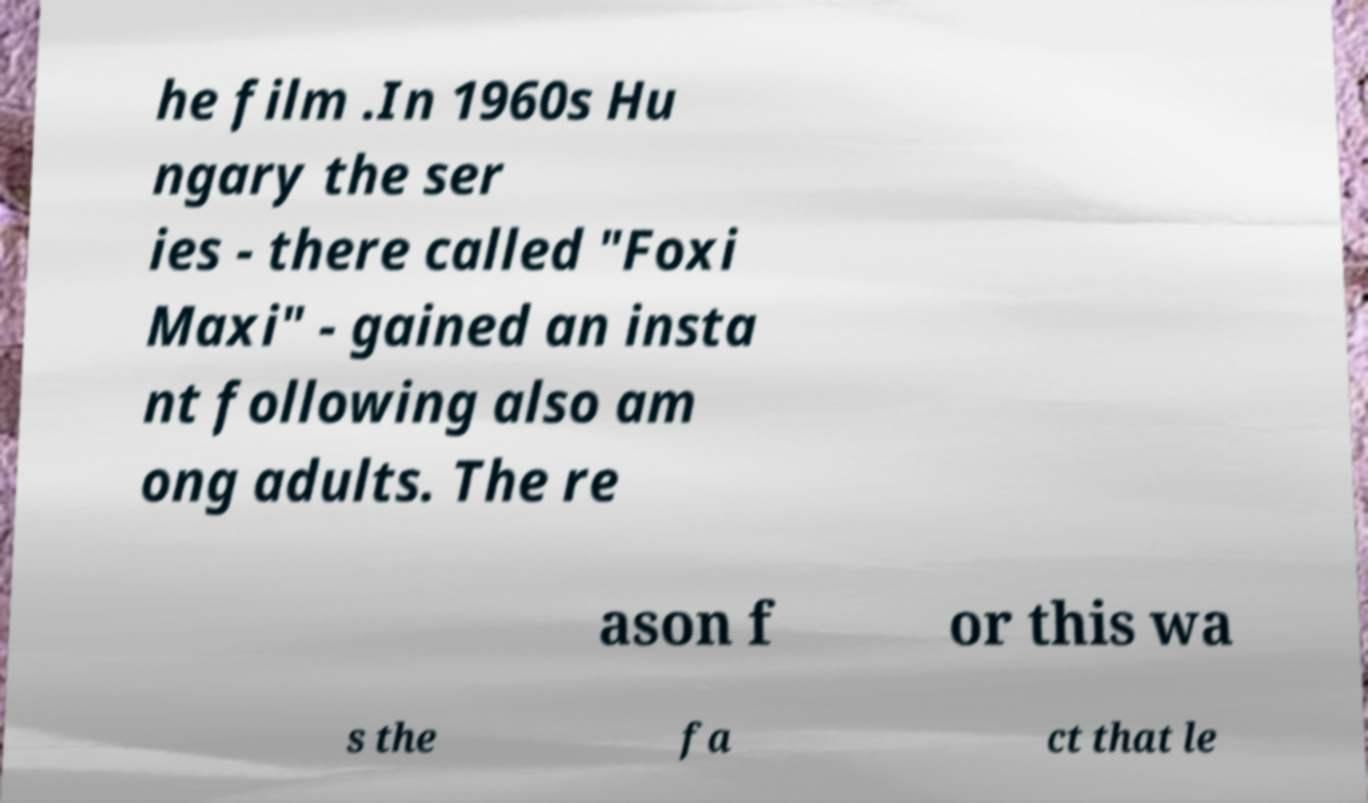Please identify and transcribe the text found in this image. he film .In 1960s Hu ngary the ser ies - there called "Foxi Maxi" - gained an insta nt following also am ong adults. The re ason f or this wa s the fa ct that le 